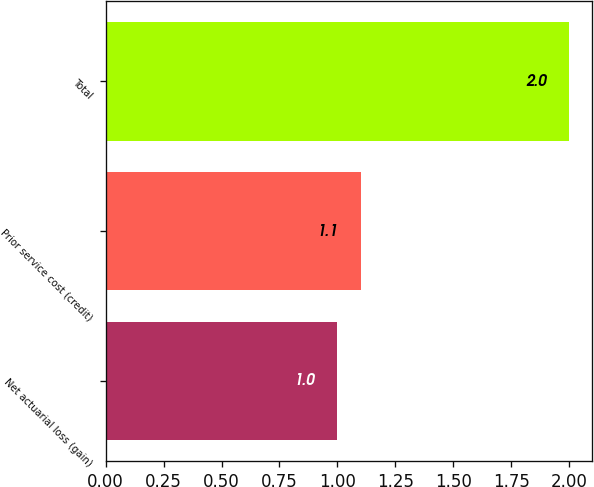Convert chart to OTSL. <chart><loc_0><loc_0><loc_500><loc_500><bar_chart><fcel>Net actuarial loss (gain)<fcel>Prior service cost (credit)<fcel>Total<nl><fcel>1<fcel>1.1<fcel>2<nl></chart> 